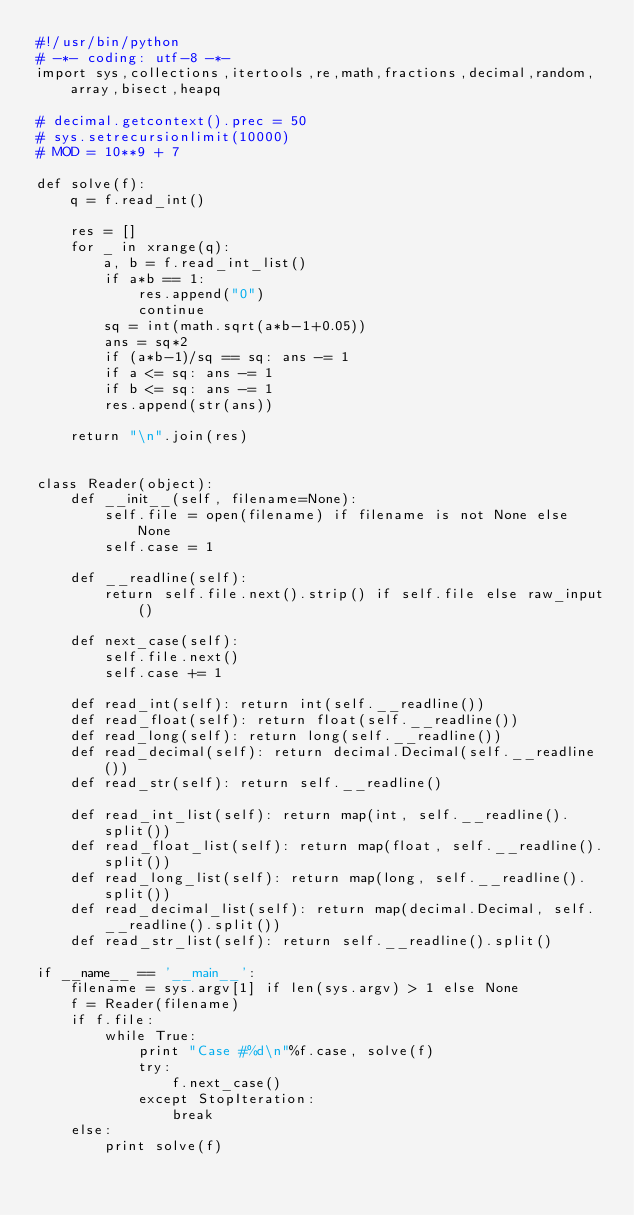<code> <loc_0><loc_0><loc_500><loc_500><_Python_>#!/usr/bin/python
# -*- coding: utf-8 -*-
import sys,collections,itertools,re,math,fractions,decimal,random,array,bisect,heapq

# decimal.getcontext().prec = 50
# sys.setrecursionlimit(10000)
# MOD = 10**9 + 7

def solve(f):
    q = f.read_int()

    res = []
    for _ in xrange(q):
        a, b = f.read_int_list()
        if a*b == 1:
            res.append("0")
            continue
        sq = int(math.sqrt(a*b-1+0.05))
        ans = sq*2
        if (a*b-1)/sq == sq: ans -= 1
        if a <= sq: ans -= 1
        if b <= sq: ans -= 1
        res.append(str(ans))

    return "\n".join(res)


class Reader(object):
    def __init__(self, filename=None):
        self.file = open(filename) if filename is not None else None
        self.case = 1

    def __readline(self):
        return self.file.next().strip() if self.file else raw_input()

    def next_case(self):
        self.file.next()
        self.case += 1

    def read_int(self): return int(self.__readline())
    def read_float(self): return float(self.__readline())
    def read_long(self): return long(self.__readline())
    def read_decimal(self): return decimal.Decimal(self.__readline())
    def read_str(self): return self.__readline()

    def read_int_list(self): return map(int, self.__readline().split())
    def read_float_list(self): return map(float, self.__readline().split())
    def read_long_list(self): return map(long, self.__readline().split())
    def read_decimal_list(self): return map(decimal.Decimal, self.__readline().split())
    def read_str_list(self): return self.__readline().split()

if __name__ == '__main__':
    filename = sys.argv[1] if len(sys.argv) > 1 else None
    f = Reader(filename)
    if f.file:
        while True:
            print "Case #%d\n"%f.case, solve(f)
            try:
                f.next_case()
            except StopIteration:
                break
    else:
        print solve(f)
</code> 